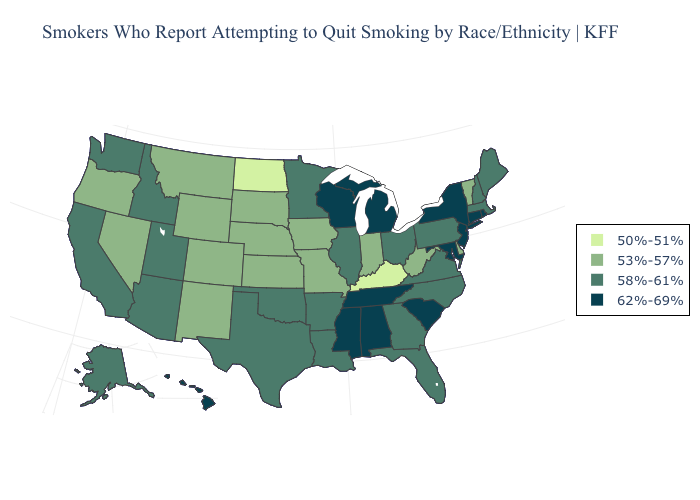Among the states that border North Carolina , which have the highest value?
Concise answer only. South Carolina, Tennessee. Name the states that have a value in the range 62%-69%?
Answer briefly. Alabama, Connecticut, Hawaii, Maryland, Michigan, Mississippi, New Jersey, New York, Rhode Island, South Carolina, Tennessee, Wisconsin. Does South Carolina have the lowest value in the USA?
Write a very short answer. No. What is the highest value in the South ?
Keep it brief. 62%-69%. Among the states that border Ohio , does Pennsylvania have the lowest value?
Answer briefly. No. Among the states that border Connecticut , does New York have the lowest value?
Give a very brief answer. No. Does Georgia have the same value as Nebraska?
Answer briefly. No. Which states have the lowest value in the South?
Answer briefly. Kentucky. What is the value of Minnesota?
Answer briefly. 58%-61%. Name the states that have a value in the range 62%-69%?
Be succinct. Alabama, Connecticut, Hawaii, Maryland, Michigan, Mississippi, New Jersey, New York, Rhode Island, South Carolina, Tennessee, Wisconsin. What is the value of New Mexico?
Answer briefly. 53%-57%. Name the states that have a value in the range 58%-61%?
Short answer required. Alaska, Arizona, Arkansas, California, Florida, Georgia, Idaho, Illinois, Louisiana, Maine, Massachusetts, Minnesota, New Hampshire, North Carolina, Ohio, Oklahoma, Pennsylvania, Texas, Utah, Virginia, Washington. Which states have the highest value in the USA?
Give a very brief answer. Alabama, Connecticut, Hawaii, Maryland, Michigan, Mississippi, New Jersey, New York, Rhode Island, South Carolina, Tennessee, Wisconsin. What is the value of Iowa?
Answer briefly. 53%-57%. What is the value of Arkansas?
Quick response, please. 58%-61%. 